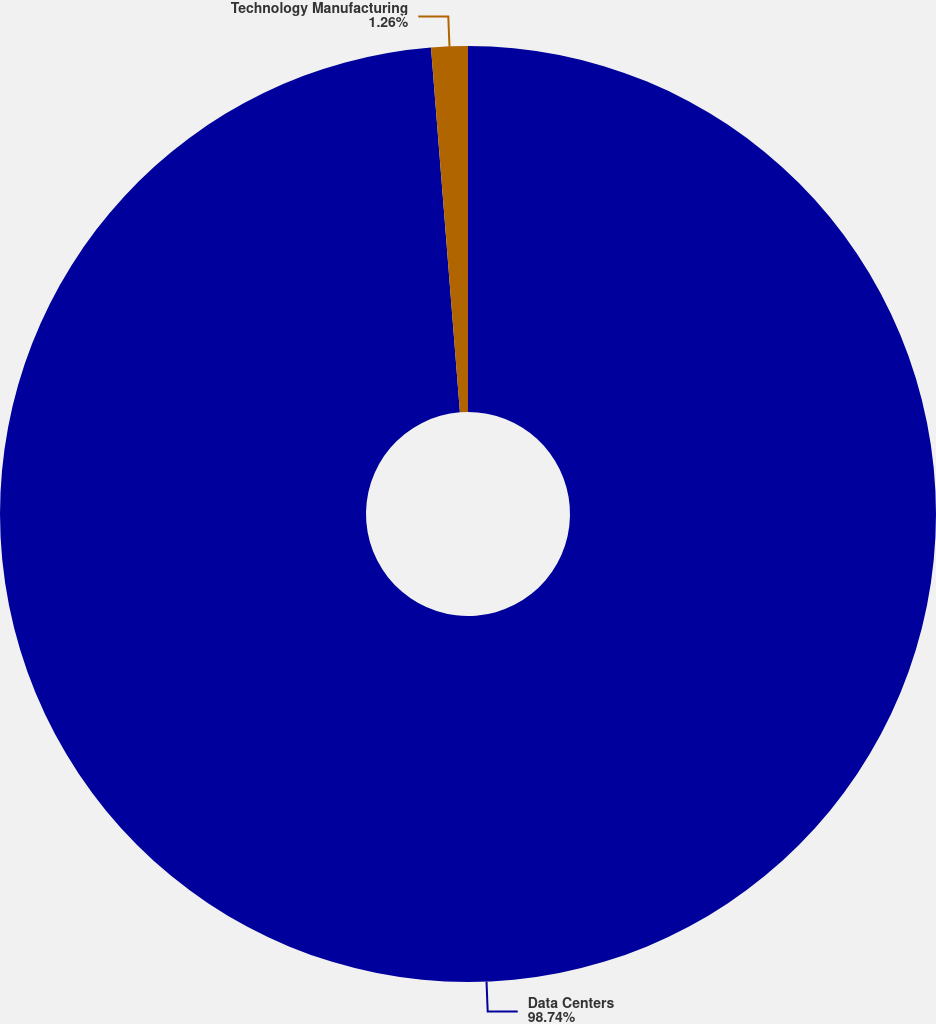Convert chart. <chart><loc_0><loc_0><loc_500><loc_500><pie_chart><fcel>Data Centers<fcel>Technology Manufacturing<nl><fcel>98.74%<fcel>1.26%<nl></chart> 